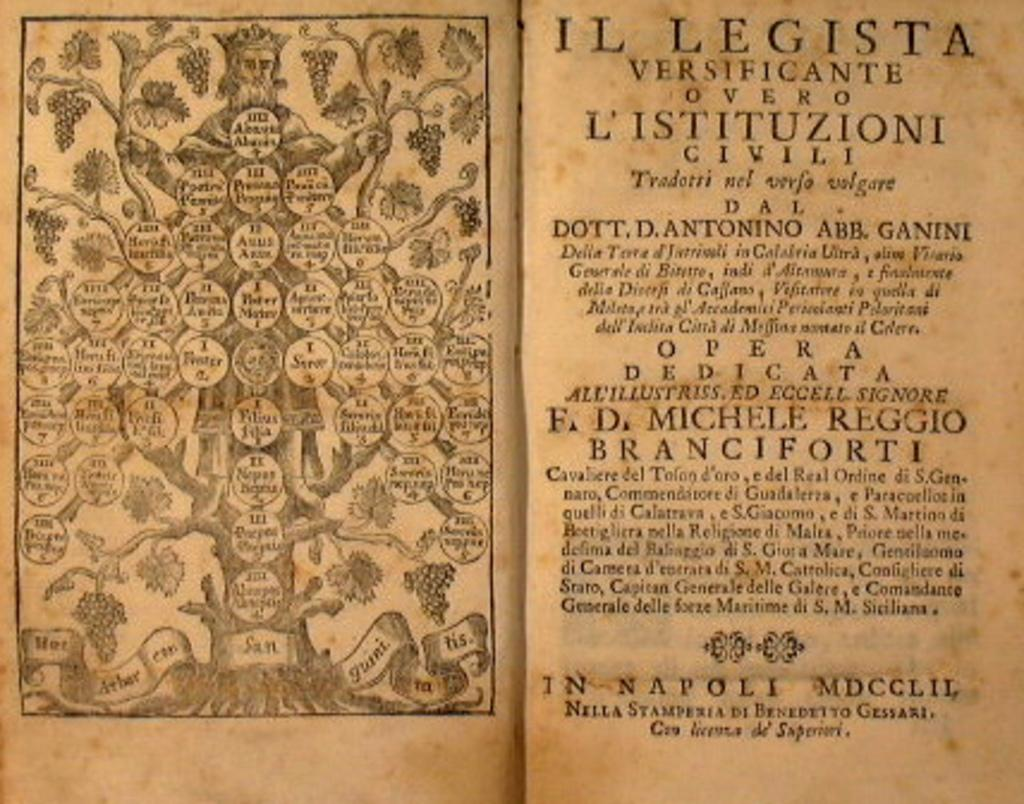What type of content is visible on the front pages of the book in the image? The image contains the front pages of a book. How many cakes are displayed on the front pages of the book in the image? There are no cakes present on the front pages of the book in the image. 